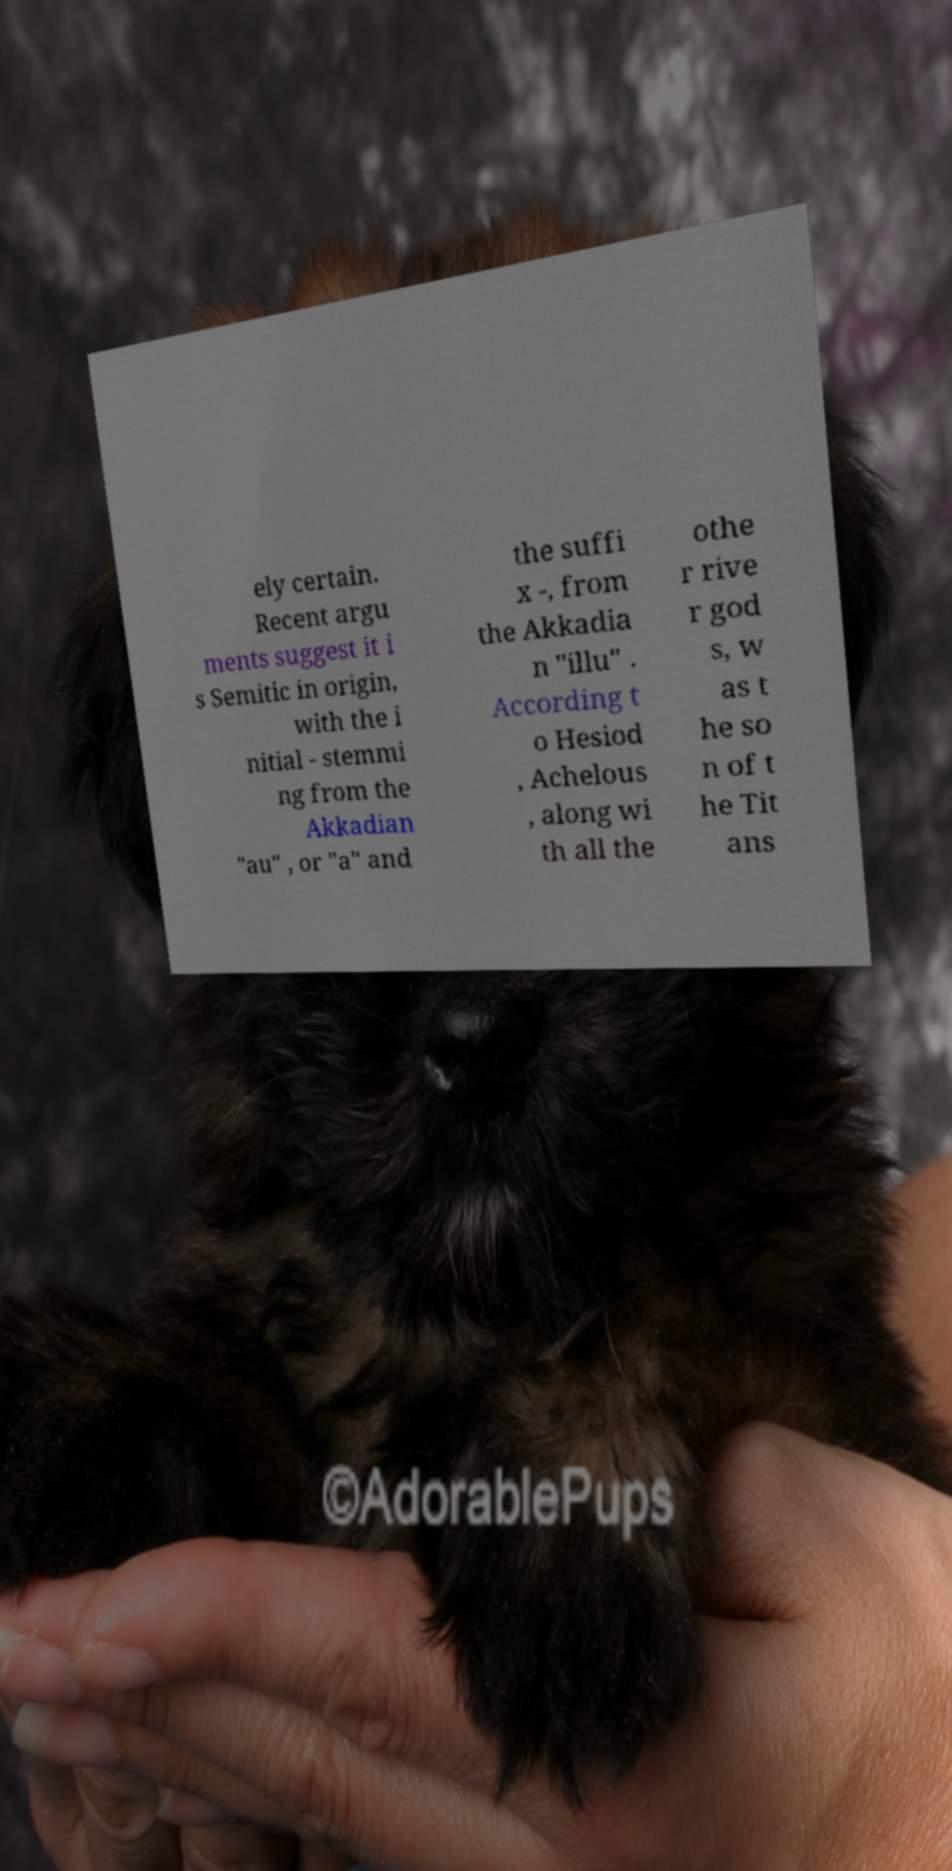Please read and relay the text visible in this image. What does it say? ely certain. Recent argu ments suggest it i s Semitic in origin, with the i nitial - stemmi ng from the Akkadian "au" , or "a" and the suffi x -, from the Akkadia n "illu" . According t o Hesiod , Achelous , along wi th all the othe r rive r god s, w as t he so n of t he Tit ans 